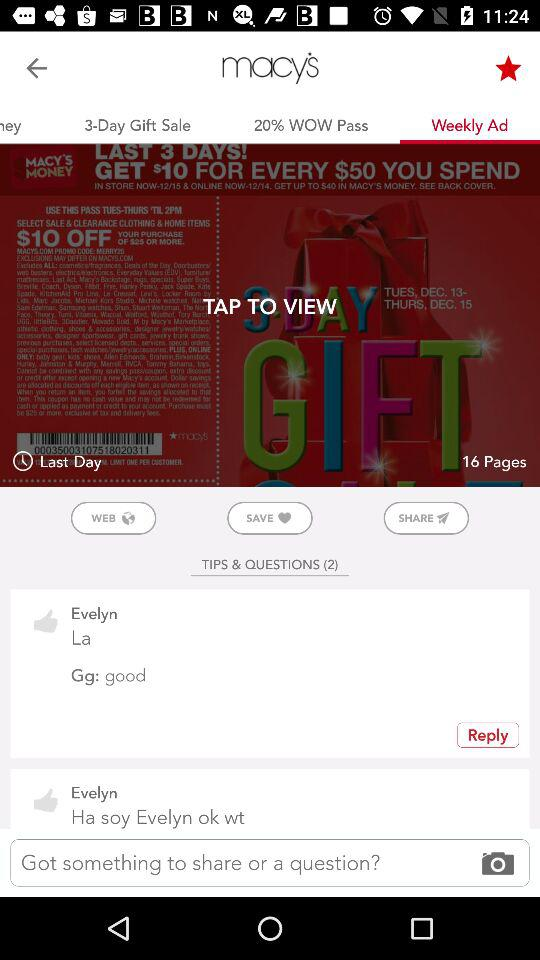How many tips and questions are there? There are a total of 2 tips and questions. 